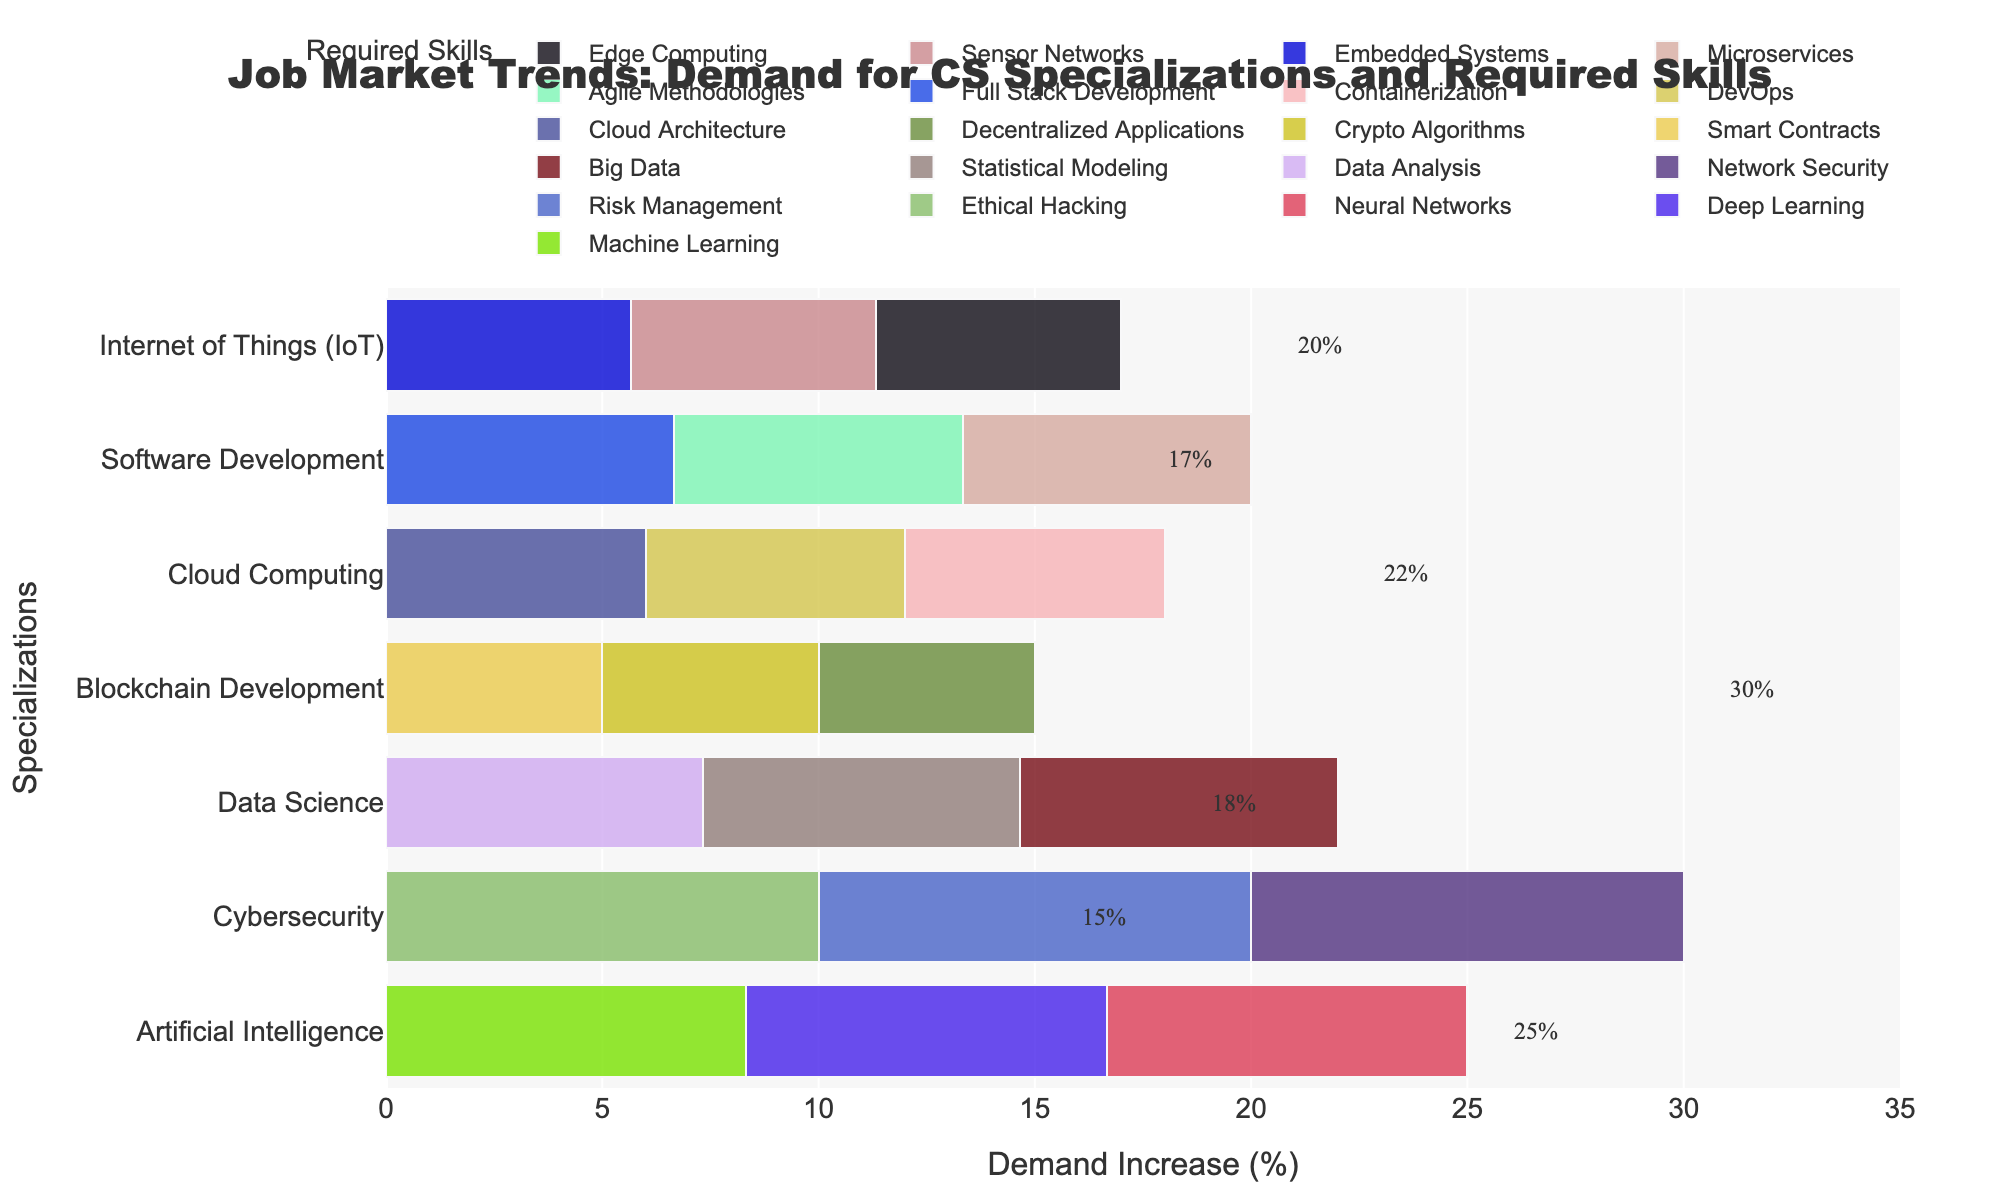What's the specialization with the highest demand increase? The highest demand increase value is 30%, which is associated with Cybersecurity. Just look for the highest percentage label on the bar chart.
Answer: Cybersecurity Which specialization has the lowest demand increase and what's the percentage? The lowest demand increase percentage in the figure is 15%, which corresponds to Blockchain Development. This can be seen by finding the lowest demand percentage label on the y-axis.
Answer: Blockchain Development, 15% Compare the demand increases between Artificial Intelligence and Data Science specializations. Artificial Intelligence and Data Science both have multiple bars representing required skills. However, each specialization overall has a single demand increase percentage label. For Artificial Intelligence, it's 25%, and for Data Science, it's 22%. 25% is greater than 22%, so the demand increase for Artificial Intelligence is higher.
Answer: Artificial Intelligence has a higher demand increase What are the required skills for Cybersecurity, and how much is its demand increase? Cybersecurity has several bars aligned horizontally on the y-axis labeled "Cybersecurity." The skills listed for these bars are Ethical Hacking, Risk Management, and Network Security. The overall demand increase for Cybersecurity is 30%, as shown by the demand percentage label.
Answer: Ethical Hacking, Risk Management, Network Security; 30% By how much did the demand for Cloud Computing increase compared to IoT? Cloud Computing has a demand increase of 18%, while IoT has a demand increase of 17%. Therefore, the difference in the demand increase between Cloud Computing and IoT is 18% - 17% = 1%.
Answer: 1% What's the combined demand increase percentage for Artificial Intelligence and Cloud Computing? The demand increase percentage for Artificial Intelligence is 25%, and for Cloud Computing, it is 18%. Adding these percentages together, we get 25% + 18% = 43%.
Answer: 43% Which specialization has a demand increase closest to 20%? The specializations listed on the y-axis have associated percentage labels for demand increases. Software Development has a demand increase of 20%, which exactly matches the 20% query.
Answer: Software Development Which skill is associated with the highest-colored bar in Data Science? To identify the skill with the highest-colored bar specific to Data Science, look for the longest bar within the "Data Science" category. In the Data Science category (at 22%), the bars for Data Analysis, Statistical Modeling, and Big Data appear. Each has the same length visually because they represent skills with approximately equal relevance to Data Science. However, considering the similar length bars and proportion comparisons to other skills, all are equivalently represented.
Answer: Data Analysis, Statistical Modeling, Big Data How does the demand increase for Blockchain Development compare to Software Development? The demand increase for Blockchain Development is 15%, and for Software Development, it is 20%. By comparing these numbers, we find that Software Development has a higher demand increase than Blockchain Development by 20% - 15% = 5%.
Answer: Software Development has a 5% higher demand increase 